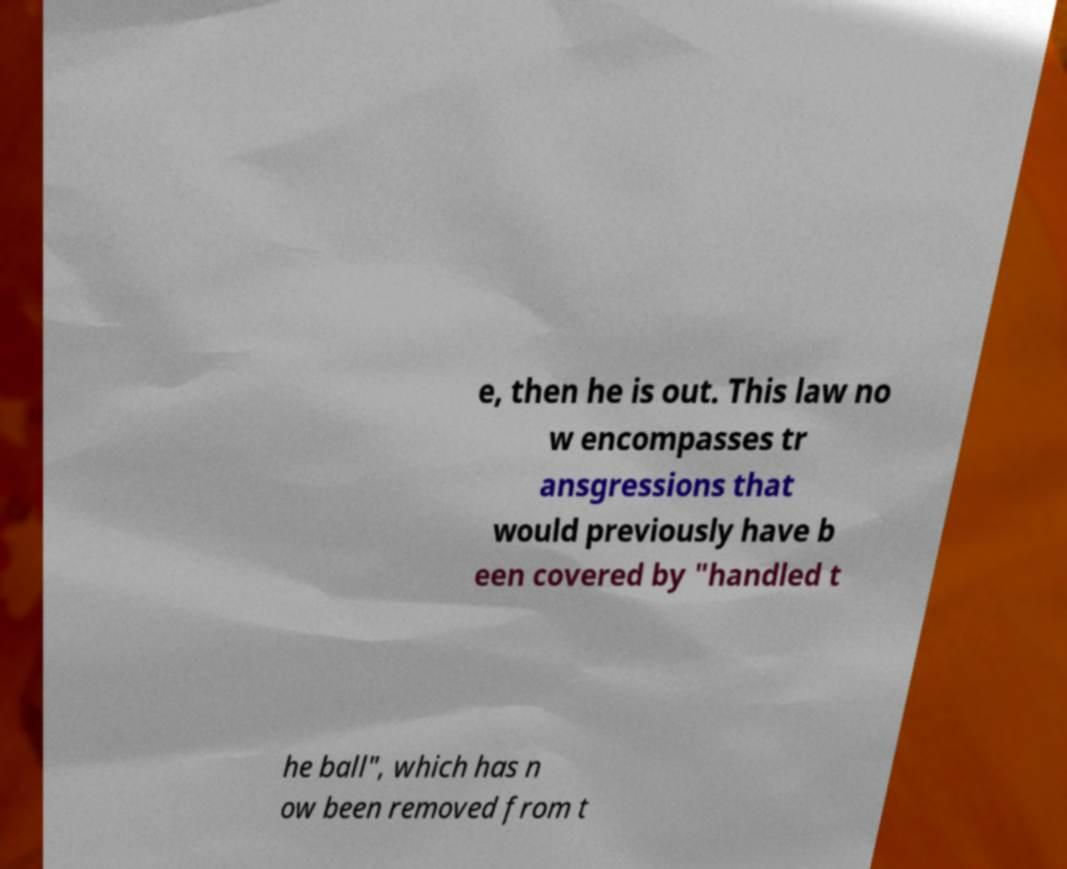Please identify and transcribe the text found in this image. e, then he is out. This law no w encompasses tr ansgressions that would previously have b een covered by "handled t he ball", which has n ow been removed from t 